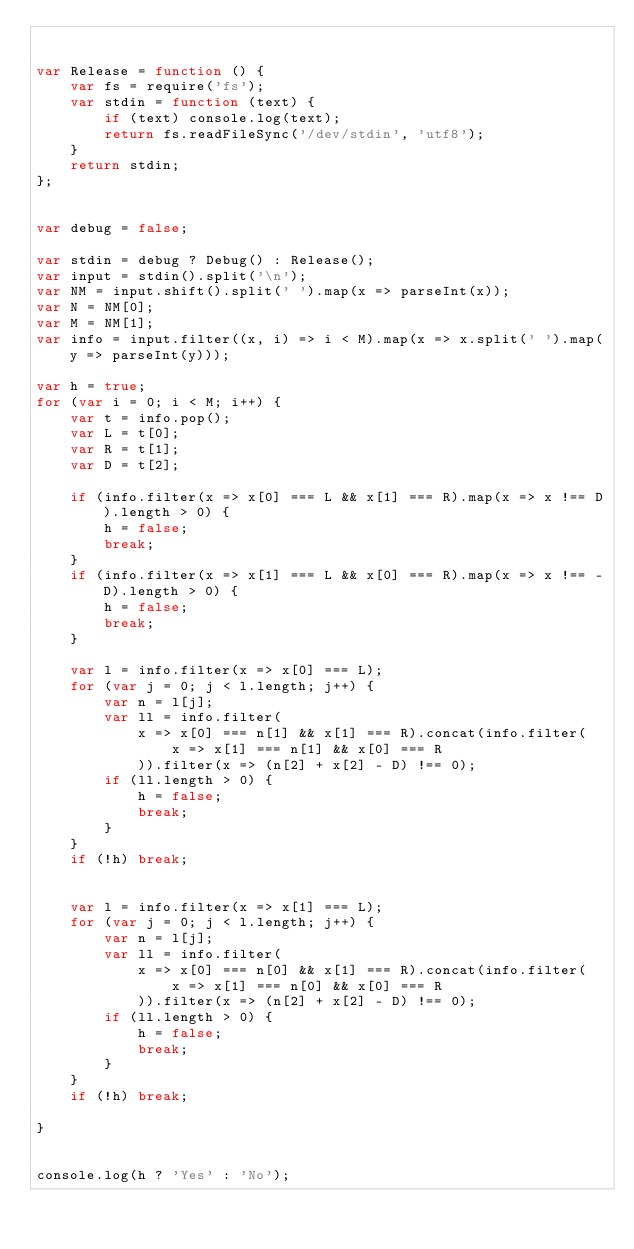<code> <loc_0><loc_0><loc_500><loc_500><_JavaScript_>

var Release = function () {
    var fs = require('fs');
    var stdin = function (text) {
        if (text) console.log(text);
        return fs.readFileSync('/dev/stdin', 'utf8');
    }
    return stdin;
};


var debug = false;

var stdin = debug ? Debug() : Release();
var input = stdin().split('\n');
var NM = input.shift().split(' ').map(x => parseInt(x));
var N = NM[0];
var M = NM[1];
var info = input.filter((x, i) => i < M).map(x => x.split(' ').map(y => parseInt(y)));

var h = true;
for (var i = 0; i < M; i++) {
    var t = info.pop();
    var L = t[0];
    var R = t[1];
    var D = t[2];

    if (info.filter(x => x[0] === L && x[1] === R).map(x => x !== D).length > 0) {
        h = false;
        break;
    }
    if (info.filter(x => x[1] === L && x[0] === R).map(x => x !== -D).length > 0) {
        h = false;
        break;
    }

    var l = info.filter(x => x[0] === L);
    for (var j = 0; j < l.length; j++) {
        var n = l[j];
        var ll = info.filter(
            x => x[0] === n[1] && x[1] === R).concat(info.filter(
                x => x[1] === n[1] && x[0] === R
            )).filter(x => (n[2] + x[2] - D) !== 0);
        if (ll.length > 0) {
            h = false;
            break;
        }
    }
    if (!h) break;


    var l = info.filter(x => x[1] === L);
    for (var j = 0; j < l.length; j++) {
        var n = l[j];
        var ll = info.filter(
            x => x[0] === n[0] && x[1] === R).concat(info.filter(
                x => x[1] === n[0] && x[0] === R
            )).filter(x => (n[2] + x[2] - D) !== 0);
        if (ll.length > 0) {
            h = false;
            break;
        }
    }
    if (!h) break;

}


console.log(h ? 'Yes' : 'No');</code> 